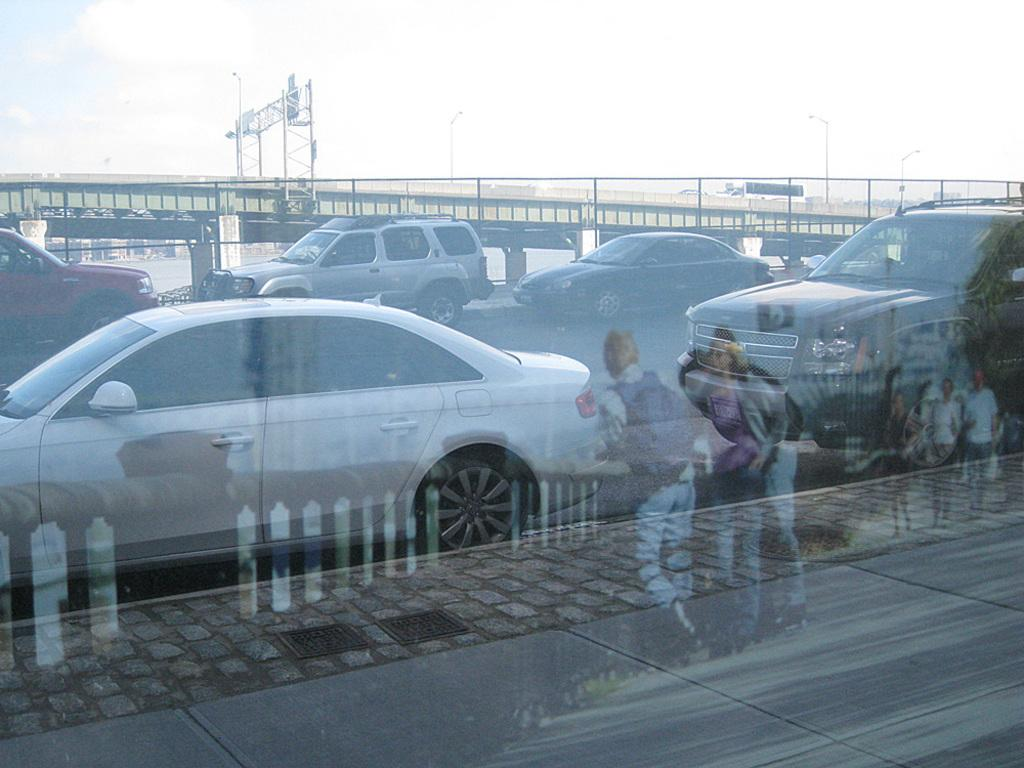What can be seen on the road in the image? There are cars on the road in the image. What structure is present in the image that allows vehicles to cross over a body of water? There is a bridge in the image. What type of advertisement or announcement can be seen in the image? There is a hoarding in the image. What is visible in the background of the image? The sky is visible in the image. What is reflecting the image of persons in the image? There is a reflection of persons on a mirror in the image. What type of wax is being used to expand the soap in the image? There is no wax or soap present in the image. How does the expansion of the soap affect the bridge in the image? There is no expansion of soap in the image, and the bridge is not affected by any such event. 